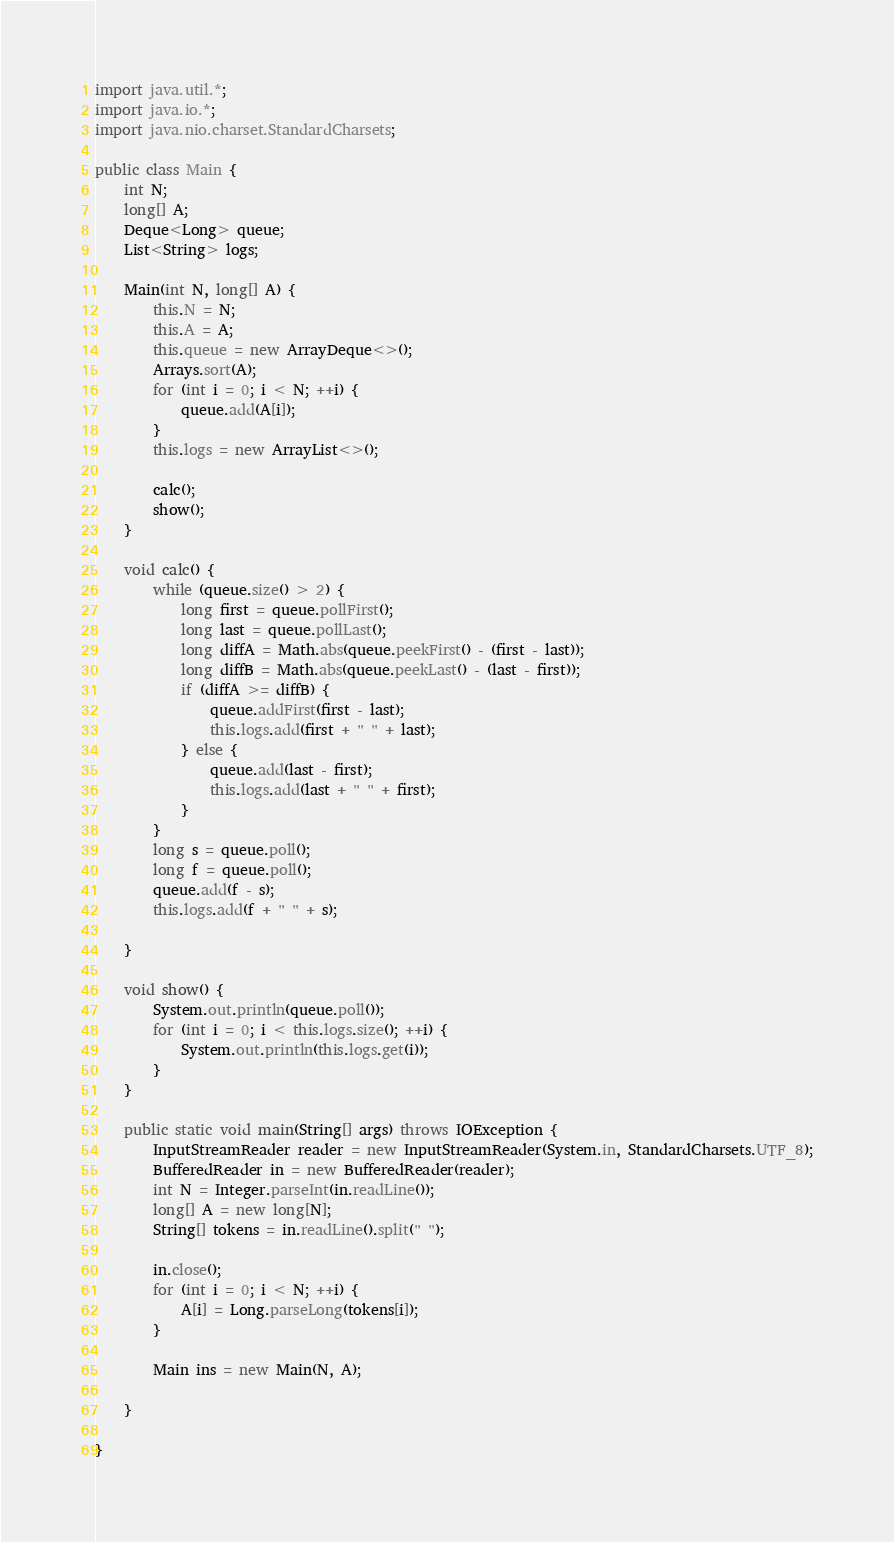<code> <loc_0><loc_0><loc_500><loc_500><_Java_>import java.util.*;
import java.io.*;
import java.nio.charset.StandardCharsets;

public class Main {
	int N;
	long[] A;
	Deque<Long> queue;
	List<String> logs;

	Main(int N, long[] A) {
		this.N = N;
		this.A = A;
		this.queue = new ArrayDeque<>();
		Arrays.sort(A);
		for (int i = 0; i < N; ++i) {
			queue.add(A[i]);
		}
		this.logs = new ArrayList<>();

		calc();
		show();
	}

	void calc() {
		while (queue.size() > 2) {
			long first = queue.pollFirst();
			long last = queue.pollLast();
			long diffA = Math.abs(queue.peekFirst() - (first - last));
			long diffB = Math.abs(queue.peekLast() - (last - first));
			if (diffA >= diffB) {
				queue.addFirst(first - last);
				this.logs.add(first + " " + last);
			} else {
				queue.add(last - first);
				this.logs.add(last + " " + first);
			}
		}
		long s = queue.poll();
		long f = queue.poll();
		queue.add(f - s);
		this.logs.add(f + " " + s);

	}

	void show() {
		System.out.println(queue.poll());
		for (int i = 0; i < this.logs.size(); ++i) {
			System.out.println(this.logs.get(i));
		}
	}

	public static void main(String[] args) throws IOException {
		InputStreamReader reader = new InputStreamReader(System.in, StandardCharsets.UTF_8);
		BufferedReader in = new BufferedReader(reader);
		int N = Integer.parseInt(in.readLine());
		long[] A = new long[N];
		String[] tokens = in.readLine().split(" ");

		in.close();
		for (int i = 0; i < N; ++i) {
			A[i] = Long.parseLong(tokens[i]);
		}

		Main ins = new Main(N, A);

	}

}</code> 